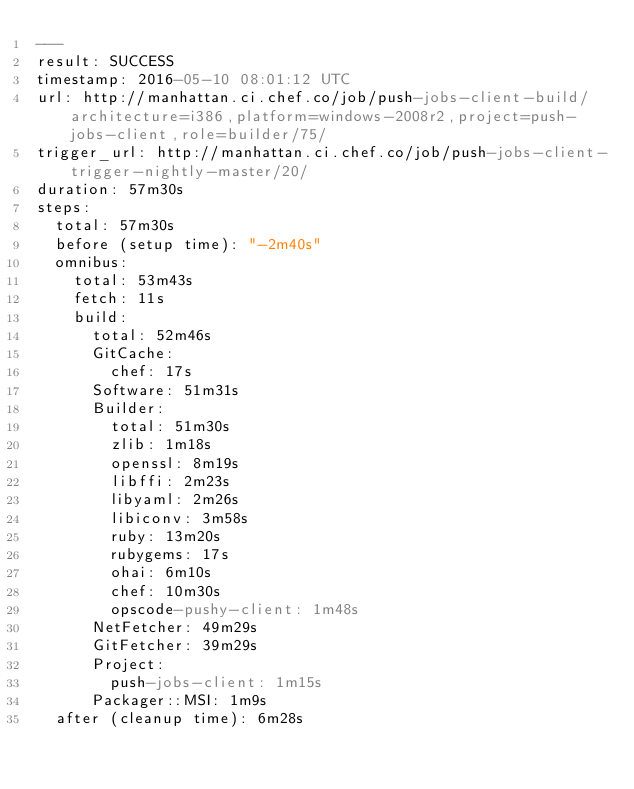Convert code to text. <code><loc_0><loc_0><loc_500><loc_500><_YAML_>---
result: SUCCESS
timestamp: 2016-05-10 08:01:12 UTC
url: http://manhattan.ci.chef.co/job/push-jobs-client-build/architecture=i386,platform=windows-2008r2,project=push-jobs-client,role=builder/75/
trigger_url: http://manhattan.ci.chef.co/job/push-jobs-client-trigger-nightly-master/20/
duration: 57m30s
steps:
  total: 57m30s
  before (setup time): "-2m40s"
  omnibus:
    total: 53m43s
    fetch: 11s
    build:
      total: 52m46s
      GitCache:
        chef: 17s
      Software: 51m31s
      Builder:
        total: 51m30s
        zlib: 1m18s
        openssl: 8m19s
        libffi: 2m23s
        libyaml: 2m26s
        libiconv: 3m58s
        ruby: 13m20s
        rubygems: 17s
        ohai: 6m10s
        chef: 10m30s
        opscode-pushy-client: 1m48s
      NetFetcher: 49m29s
      GitFetcher: 39m29s
      Project:
        push-jobs-client: 1m15s
      Packager::MSI: 1m9s
  after (cleanup time): 6m28s
</code> 